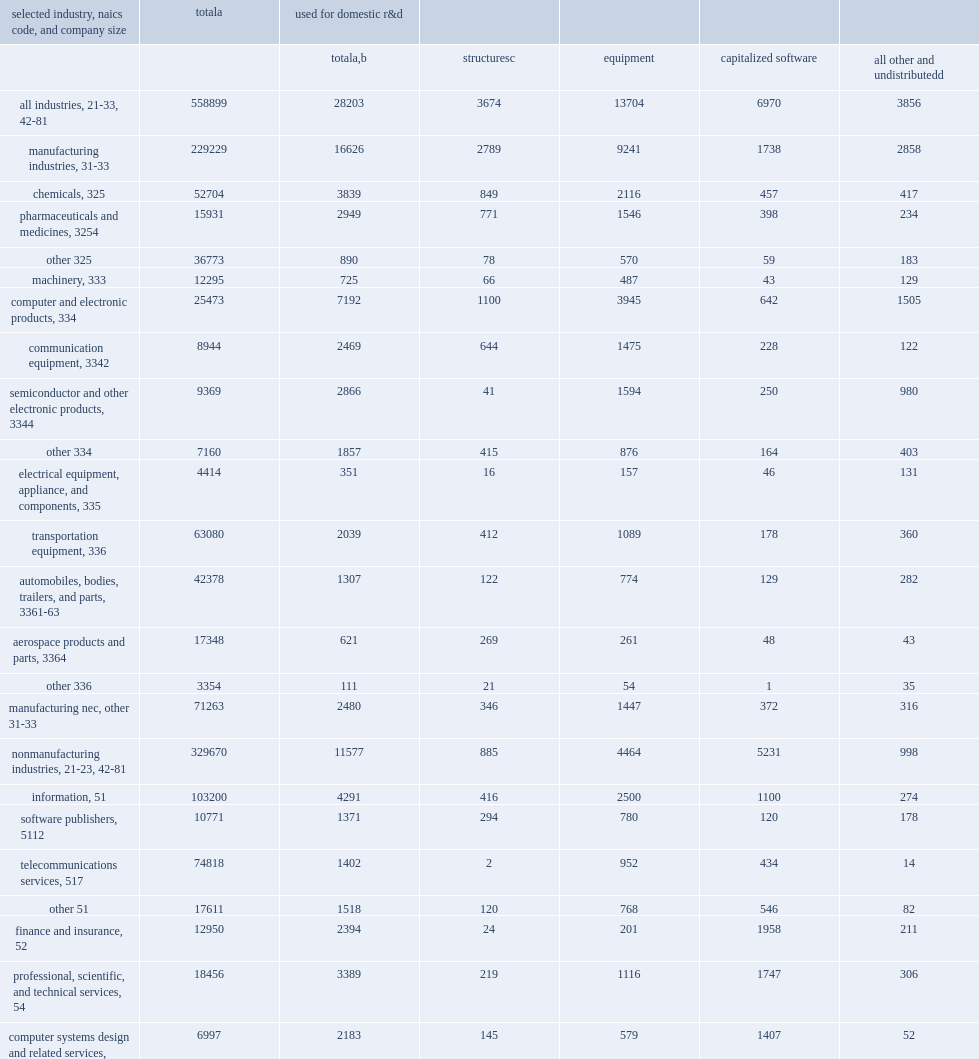How many million dollars did companies that performed r&d in the united states in 2015 spend on assets with expected useful lives of more than 1 year? 558899.0. How many million dollars were spent on structures, equipment, software, and other assets used for r&d? 28203.0. How many million dollars were spent by manufacturers? 16626.0. How many million dollars by companies were spent in nonmanufacturing industries? 11577.0. 